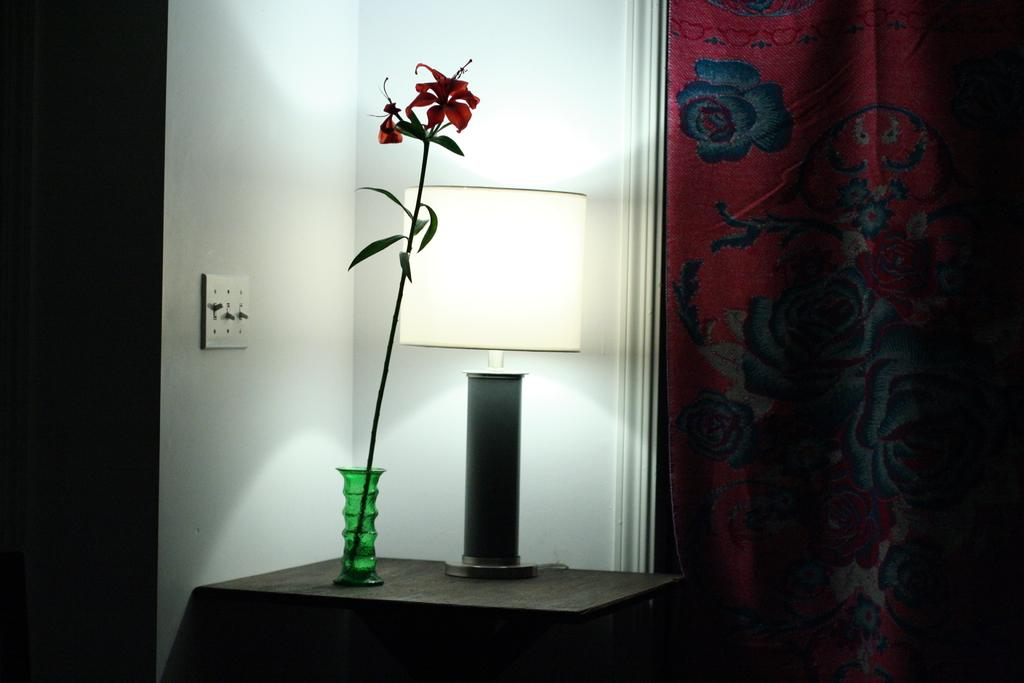What is the main object in the image? There is a stand in the image. What is placed on the stand? There is a flower vase and a lamp on the stand. What can be seen on the right side of the image? There is a curtain on the right side of the image. What is visible in the background of the image? There is a wall visible in the background of the image. Can you see any wilderness in the image? There is no wilderness present in the image; it features a stand with a flower vase and a lamp, a curtain, and a wall in the background. What type of needle is used to sew the curtain in the image? There is no needle visible in the image, and the curtain is not being sewn. 